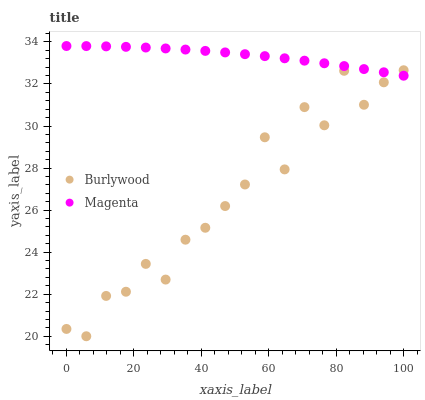Does Burlywood have the minimum area under the curve?
Answer yes or no. Yes. Does Magenta have the maximum area under the curve?
Answer yes or no. Yes. Does Magenta have the minimum area under the curve?
Answer yes or no. No. Is Magenta the smoothest?
Answer yes or no. Yes. Is Burlywood the roughest?
Answer yes or no. Yes. Is Magenta the roughest?
Answer yes or no. No. Does Burlywood have the lowest value?
Answer yes or no. Yes. Does Magenta have the lowest value?
Answer yes or no. No. Does Magenta have the highest value?
Answer yes or no. Yes. Does Burlywood intersect Magenta?
Answer yes or no. Yes. Is Burlywood less than Magenta?
Answer yes or no. No. Is Burlywood greater than Magenta?
Answer yes or no. No. 